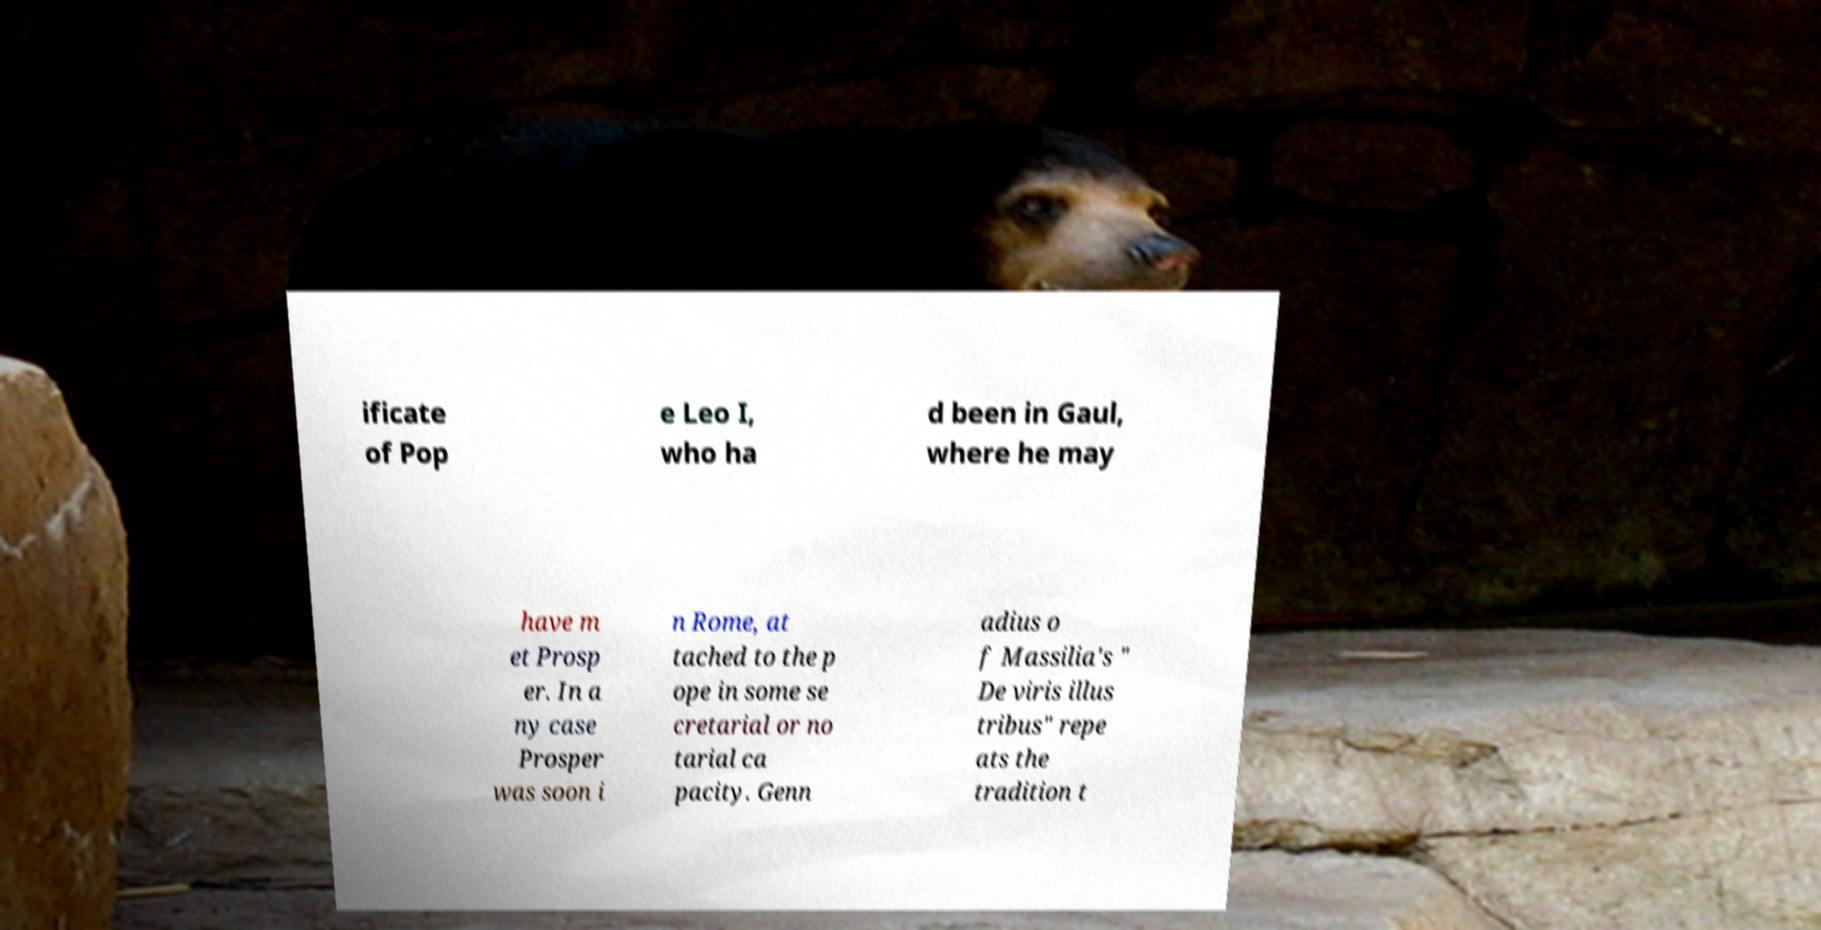There's text embedded in this image that I need extracted. Can you transcribe it verbatim? ificate of Pop e Leo I, who ha d been in Gaul, where he may have m et Prosp er. In a ny case Prosper was soon i n Rome, at tached to the p ope in some se cretarial or no tarial ca pacity. Genn adius o f Massilia's " De viris illus tribus" repe ats the tradition t 